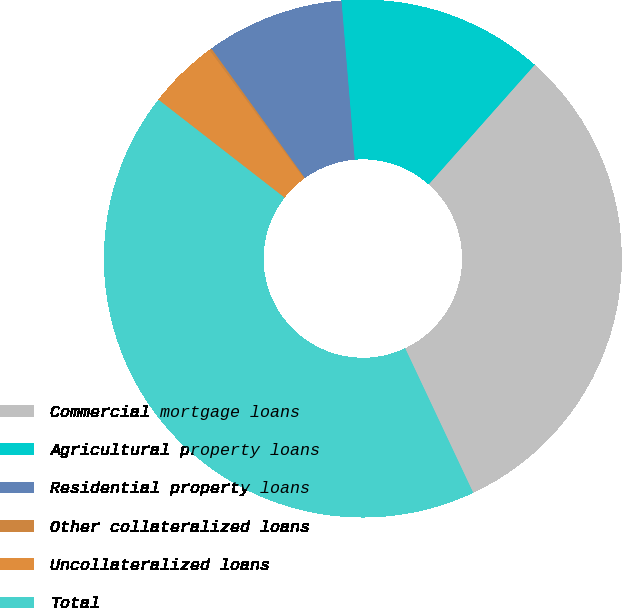Convert chart to OTSL. <chart><loc_0><loc_0><loc_500><loc_500><pie_chart><fcel>Commercial mortgage loans<fcel>Agricultural property loans<fcel>Residential property loans<fcel>Other collateralized loans<fcel>Uncollateralized loans<fcel>Total<nl><fcel>31.45%<fcel>12.87%<fcel>8.63%<fcel>0.15%<fcel>4.39%<fcel>42.52%<nl></chart> 